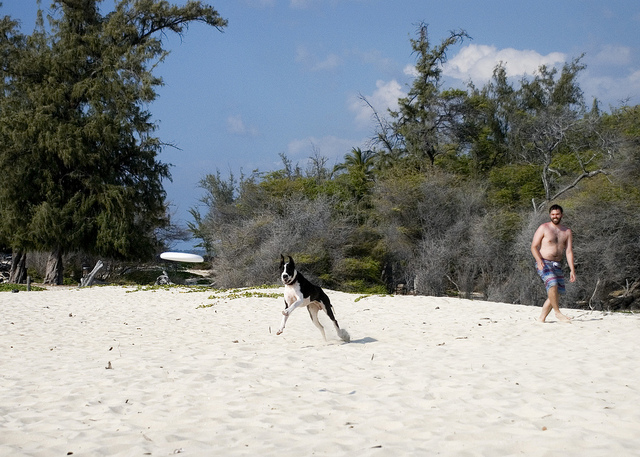<image>What type of animal is sitting on the sand? It is ambiguous what type of animal is sitting on the sand. It can be a dog or none. What type of animal is sitting on the sand? It is ambiguous what type of animal is sitting on the sand. It can be seen as a dog. 